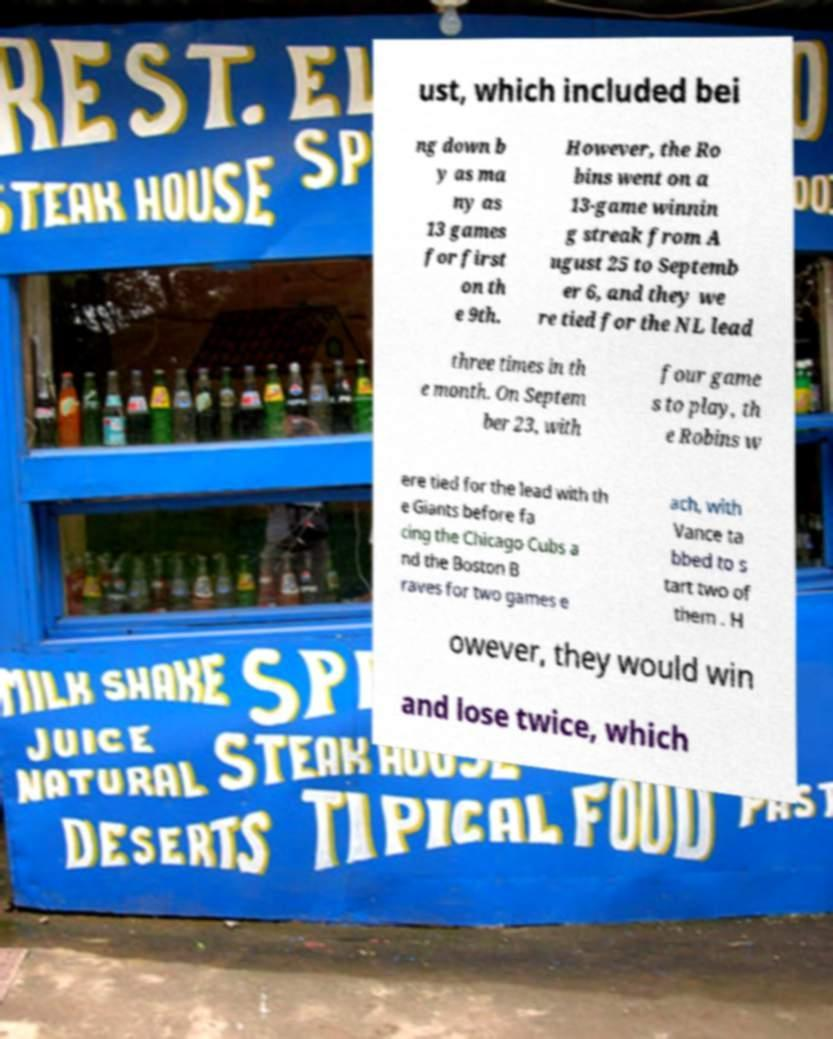Could you assist in decoding the text presented in this image and type it out clearly? ust, which included bei ng down b y as ma ny as 13 games for first on th e 9th. However, the Ro bins went on a 13-game winnin g streak from A ugust 25 to Septemb er 6, and they we re tied for the NL lead three times in th e month. On Septem ber 23, with four game s to play, th e Robins w ere tied for the lead with th e Giants before fa cing the Chicago Cubs a nd the Boston B raves for two games e ach, with Vance ta bbed to s tart two of them . H owever, they would win and lose twice, which 